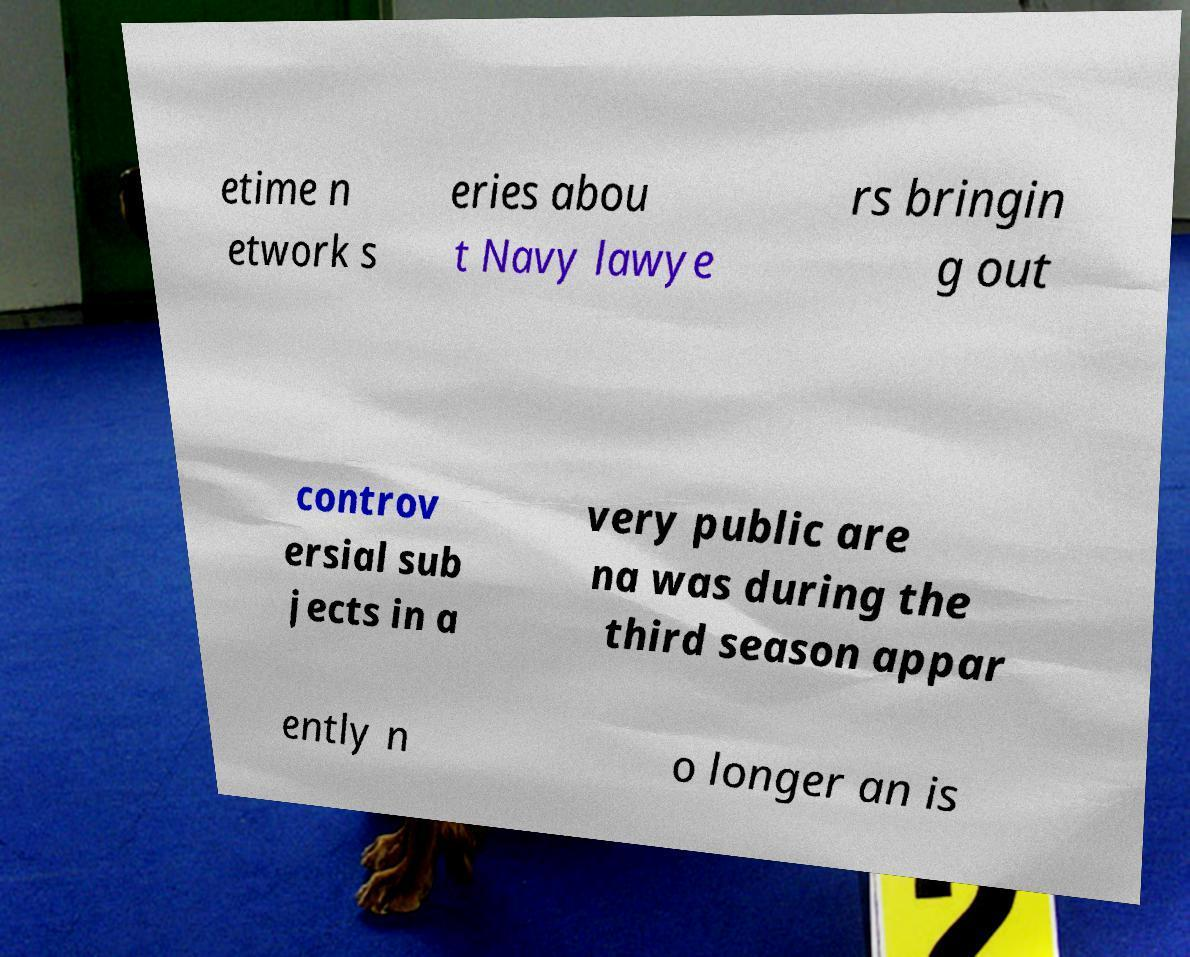Can you accurately transcribe the text from the provided image for me? etime n etwork s eries abou t Navy lawye rs bringin g out controv ersial sub jects in a very public are na was during the third season appar ently n o longer an is 